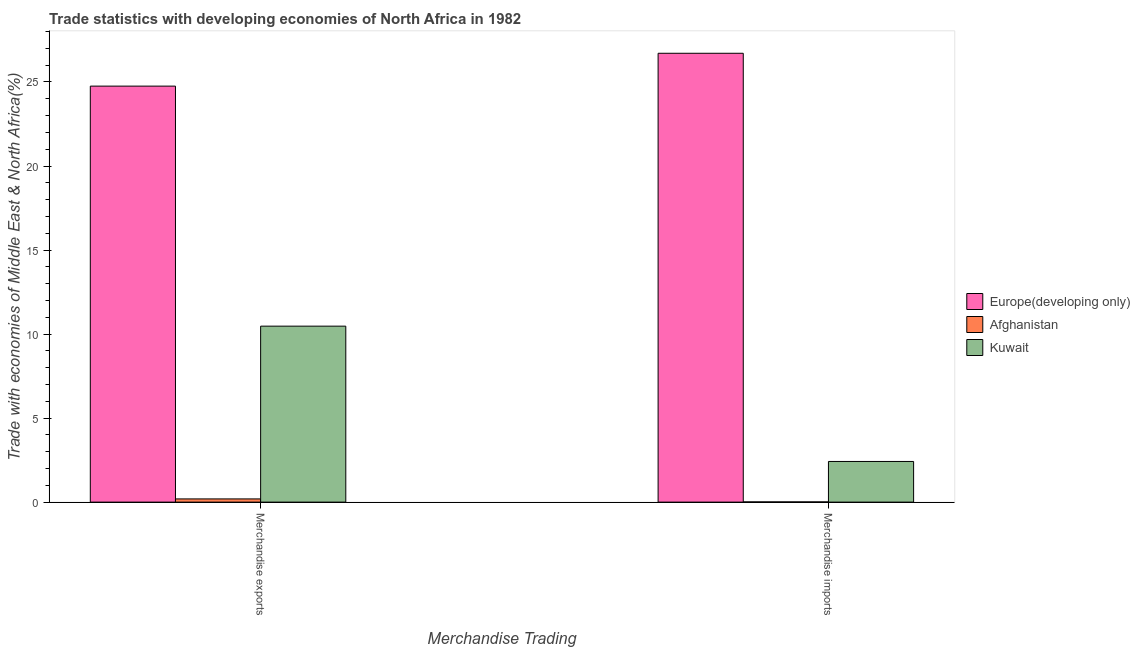How many groups of bars are there?
Give a very brief answer. 2. Are the number of bars on each tick of the X-axis equal?
Your answer should be very brief. Yes. How many bars are there on the 1st tick from the right?
Your answer should be compact. 3. What is the label of the 2nd group of bars from the left?
Keep it short and to the point. Merchandise imports. What is the merchandise imports in Kuwait?
Provide a succinct answer. 2.42. Across all countries, what is the maximum merchandise imports?
Your answer should be very brief. 26.71. Across all countries, what is the minimum merchandise imports?
Give a very brief answer. 0.01. In which country was the merchandise exports maximum?
Make the answer very short. Europe(developing only). In which country was the merchandise exports minimum?
Provide a short and direct response. Afghanistan. What is the total merchandise exports in the graph?
Offer a terse response. 35.42. What is the difference between the merchandise exports in Kuwait and that in Europe(developing only)?
Offer a terse response. -14.28. What is the difference between the merchandise imports in Europe(developing only) and the merchandise exports in Afghanistan?
Ensure brevity in your answer.  26.52. What is the average merchandise exports per country?
Your answer should be compact. 11.81. What is the difference between the merchandise imports and merchandise exports in Afghanistan?
Your answer should be very brief. -0.18. In how many countries, is the merchandise imports greater than 15 %?
Your answer should be very brief. 1. What is the ratio of the merchandise imports in Europe(developing only) to that in Kuwait?
Ensure brevity in your answer.  11.04. In how many countries, is the merchandise imports greater than the average merchandise imports taken over all countries?
Keep it short and to the point. 1. What does the 3rd bar from the left in Merchandise exports represents?
Your answer should be very brief. Kuwait. What does the 1st bar from the right in Merchandise imports represents?
Provide a short and direct response. Kuwait. Are all the bars in the graph horizontal?
Offer a very short reply. No. How many countries are there in the graph?
Provide a succinct answer. 3. What is the difference between two consecutive major ticks on the Y-axis?
Ensure brevity in your answer.  5. What is the title of the graph?
Your response must be concise. Trade statistics with developing economies of North Africa in 1982. What is the label or title of the X-axis?
Keep it short and to the point. Merchandise Trading. What is the label or title of the Y-axis?
Your response must be concise. Trade with economies of Middle East & North Africa(%). What is the Trade with economies of Middle East & North Africa(%) of Europe(developing only) in Merchandise exports?
Your answer should be very brief. 24.76. What is the Trade with economies of Middle East & North Africa(%) of Afghanistan in Merchandise exports?
Keep it short and to the point. 0.19. What is the Trade with economies of Middle East & North Africa(%) of Kuwait in Merchandise exports?
Your response must be concise. 10.47. What is the Trade with economies of Middle East & North Africa(%) of Europe(developing only) in Merchandise imports?
Your answer should be compact. 26.71. What is the Trade with economies of Middle East & North Africa(%) of Afghanistan in Merchandise imports?
Your answer should be very brief. 0.01. What is the Trade with economies of Middle East & North Africa(%) in Kuwait in Merchandise imports?
Offer a very short reply. 2.42. Across all Merchandise Trading, what is the maximum Trade with economies of Middle East & North Africa(%) of Europe(developing only)?
Your answer should be compact. 26.71. Across all Merchandise Trading, what is the maximum Trade with economies of Middle East & North Africa(%) of Afghanistan?
Your answer should be compact. 0.19. Across all Merchandise Trading, what is the maximum Trade with economies of Middle East & North Africa(%) in Kuwait?
Offer a very short reply. 10.47. Across all Merchandise Trading, what is the minimum Trade with economies of Middle East & North Africa(%) in Europe(developing only)?
Your response must be concise. 24.76. Across all Merchandise Trading, what is the minimum Trade with economies of Middle East & North Africa(%) in Afghanistan?
Provide a succinct answer. 0.01. Across all Merchandise Trading, what is the minimum Trade with economies of Middle East & North Africa(%) in Kuwait?
Your answer should be compact. 2.42. What is the total Trade with economies of Middle East & North Africa(%) of Europe(developing only) in the graph?
Provide a short and direct response. 51.46. What is the total Trade with economies of Middle East & North Africa(%) of Afghanistan in the graph?
Your answer should be compact. 0.2. What is the total Trade with economies of Middle East & North Africa(%) in Kuwait in the graph?
Offer a very short reply. 12.89. What is the difference between the Trade with economies of Middle East & North Africa(%) in Europe(developing only) in Merchandise exports and that in Merchandise imports?
Keep it short and to the point. -1.95. What is the difference between the Trade with economies of Middle East & North Africa(%) in Afghanistan in Merchandise exports and that in Merchandise imports?
Make the answer very short. 0.18. What is the difference between the Trade with economies of Middle East & North Africa(%) in Kuwait in Merchandise exports and that in Merchandise imports?
Make the answer very short. 8.05. What is the difference between the Trade with economies of Middle East & North Africa(%) in Europe(developing only) in Merchandise exports and the Trade with economies of Middle East & North Africa(%) in Afghanistan in Merchandise imports?
Offer a terse response. 24.74. What is the difference between the Trade with economies of Middle East & North Africa(%) of Europe(developing only) in Merchandise exports and the Trade with economies of Middle East & North Africa(%) of Kuwait in Merchandise imports?
Make the answer very short. 22.34. What is the difference between the Trade with economies of Middle East & North Africa(%) of Afghanistan in Merchandise exports and the Trade with economies of Middle East & North Africa(%) of Kuwait in Merchandise imports?
Give a very brief answer. -2.23. What is the average Trade with economies of Middle East & North Africa(%) of Europe(developing only) per Merchandise Trading?
Offer a terse response. 25.73. What is the average Trade with economies of Middle East & North Africa(%) in Afghanistan per Merchandise Trading?
Offer a very short reply. 0.1. What is the average Trade with economies of Middle East & North Africa(%) of Kuwait per Merchandise Trading?
Provide a succinct answer. 6.45. What is the difference between the Trade with economies of Middle East & North Africa(%) in Europe(developing only) and Trade with economies of Middle East & North Africa(%) in Afghanistan in Merchandise exports?
Ensure brevity in your answer.  24.56. What is the difference between the Trade with economies of Middle East & North Africa(%) of Europe(developing only) and Trade with economies of Middle East & North Africa(%) of Kuwait in Merchandise exports?
Offer a terse response. 14.28. What is the difference between the Trade with economies of Middle East & North Africa(%) in Afghanistan and Trade with economies of Middle East & North Africa(%) in Kuwait in Merchandise exports?
Offer a very short reply. -10.28. What is the difference between the Trade with economies of Middle East & North Africa(%) of Europe(developing only) and Trade with economies of Middle East & North Africa(%) of Afghanistan in Merchandise imports?
Offer a very short reply. 26.7. What is the difference between the Trade with economies of Middle East & North Africa(%) of Europe(developing only) and Trade with economies of Middle East & North Africa(%) of Kuwait in Merchandise imports?
Ensure brevity in your answer.  24.29. What is the difference between the Trade with economies of Middle East & North Africa(%) in Afghanistan and Trade with economies of Middle East & North Africa(%) in Kuwait in Merchandise imports?
Your answer should be compact. -2.41. What is the ratio of the Trade with economies of Middle East & North Africa(%) in Europe(developing only) in Merchandise exports to that in Merchandise imports?
Offer a terse response. 0.93. What is the ratio of the Trade with economies of Middle East & North Africa(%) of Afghanistan in Merchandise exports to that in Merchandise imports?
Keep it short and to the point. 15.37. What is the ratio of the Trade with economies of Middle East & North Africa(%) in Kuwait in Merchandise exports to that in Merchandise imports?
Your answer should be compact. 4.33. What is the difference between the highest and the second highest Trade with economies of Middle East & North Africa(%) in Europe(developing only)?
Make the answer very short. 1.95. What is the difference between the highest and the second highest Trade with economies of Middle East & North Africa(%) of Afghanistan?
Provide a succinct answer. 0.18. What is the difference between the highest and the second highest Trade with economies of Middle East & North Africa(%) of Kuwait?
Your answer should be very brief. 8.05. What is the difference between the highest and the lowest Trade with economies of Middle East & North Africa(%) of Europe(developing only)?
Provide a short and direct response. 1.95. What is the difference between the highest and the lowest Trade with economies of Middle East & North Africa(%) of Afghanistan?
Ensure brevity in your answer.  0.18. What is the difference between the highest and the lowest Trade with economies of Middle East & North Africa(%) of Kuwait?
Ensure brevity in your answer.  8.05. 